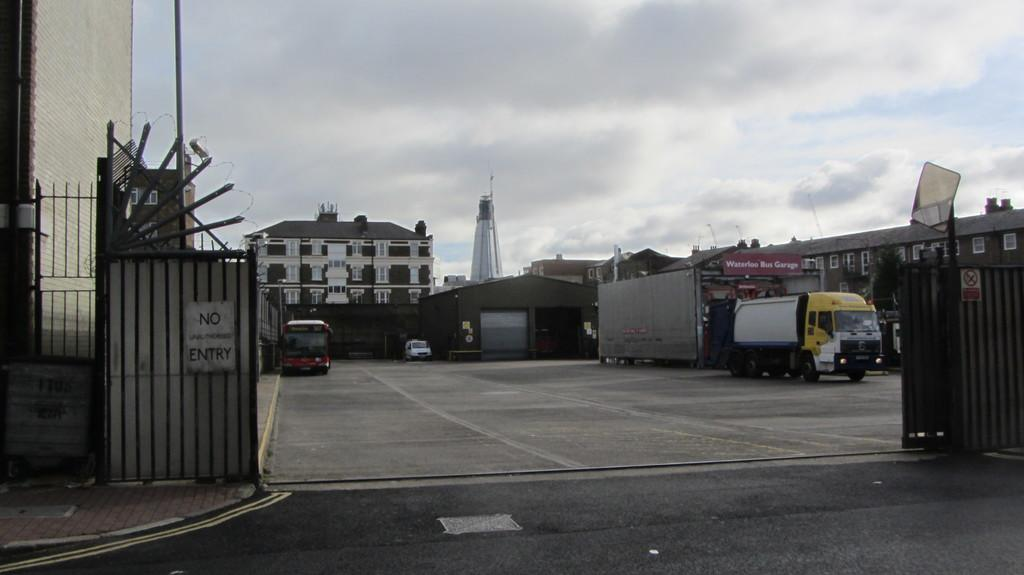What type of structures are located in the middle of the picture? There are buildings in the middle of the picture. Where are the gates positioned in the image? There is a gate on the left side and another gate on the right side of the image. What can be seen in the sky in the background of the image? There are clouds in the sky in the background of the image. What type of account is being discussed by the carpenter in the image? There is no carpenter or account present in the image. What type of trade is being conducted in the image? There is no trade being conducted in the image. 